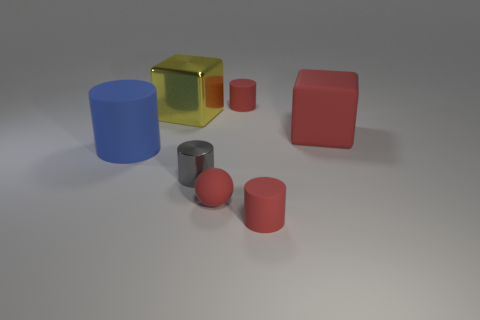Subtract all cyan cylinders. Subtract all red cubes. How many cylinders are left? 4 Add 1 big gray cubes. How many objects exist? 8 Subtract all blocks. How many objects are left? 5 Subtract all tiny red rubber objects. Subtract all rubber balls. How many objects are left? 3 Add 5 big rubber cylinders. How many big rubber cylinders are left? 6 Add 7 gray cylinders. How many gray cylinders exist? 8 Subtract 0 yellow cylinders. How many objects are left? 7 